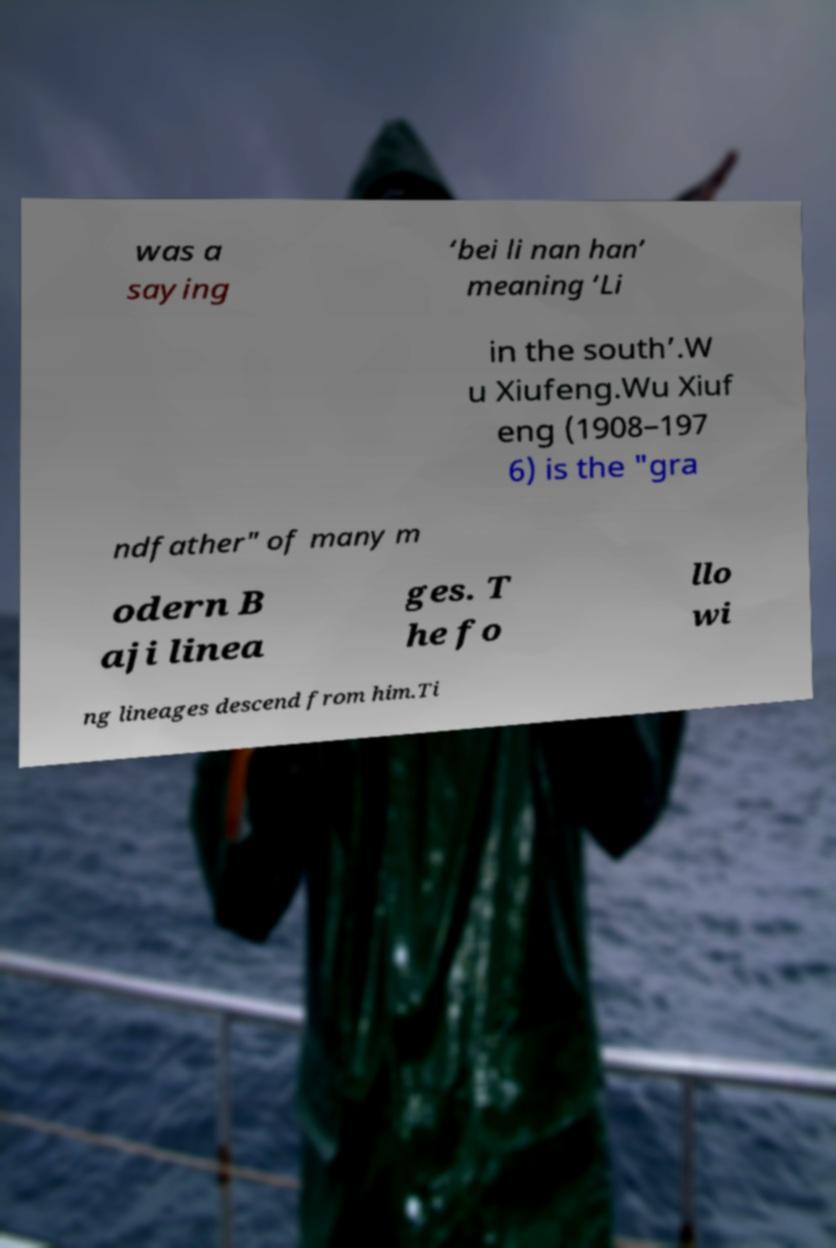Please read and relay the text visible in this image. What does it say? was a saying ‘bei li nan han’ meaning ‘Li in the south’.W u Xiufeng.Wu Xiuf eng (1908–197 6) is the "gra ndfather" of many m odern B aji linea ges. T he fo llo wi ng lineages descend from him.Ti 